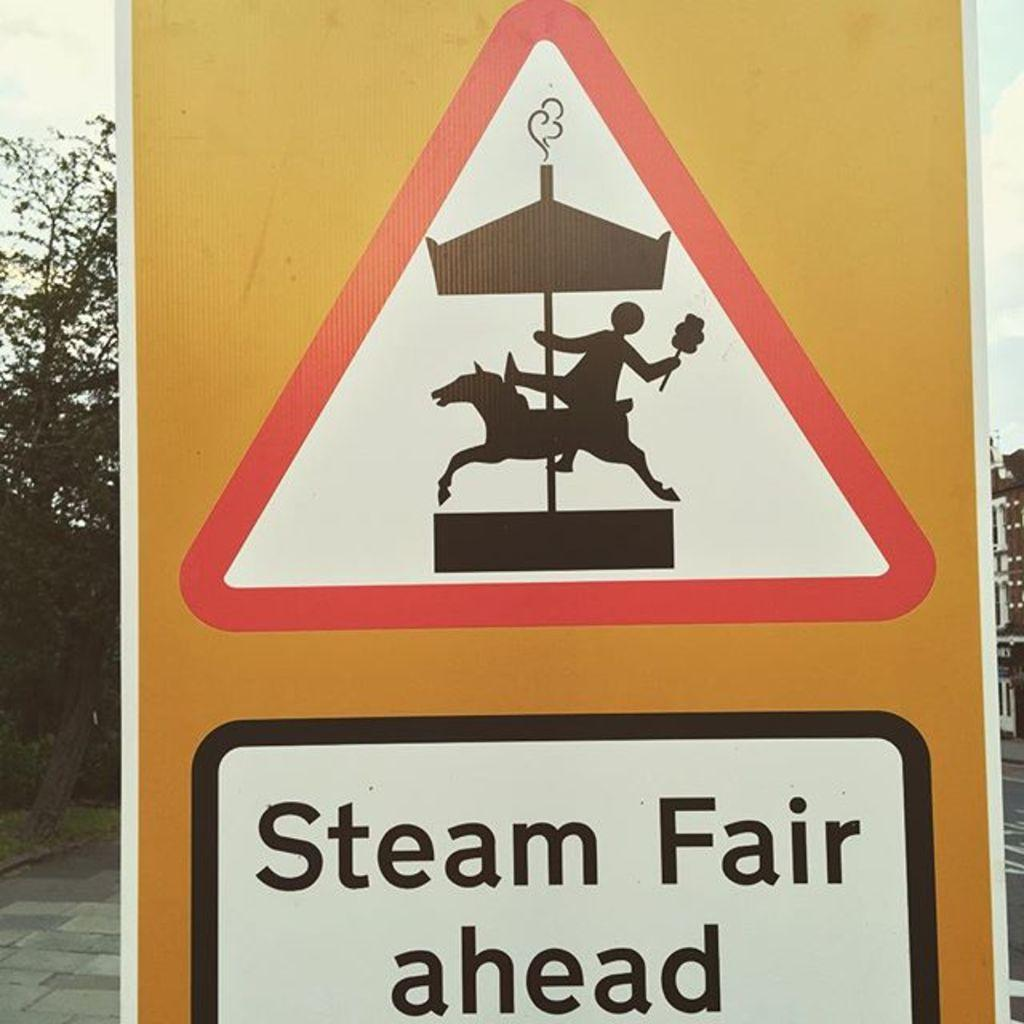<image>
Present a compact description of the photo's key features. A yellow sign shows a carousel and the direction of the Steam Fair. 